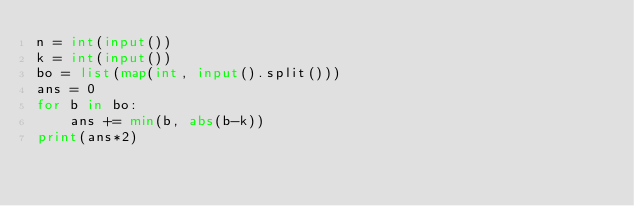<code> <loc_0><loc_0><loc_500><loc_500><_Python_>n = int(input())
k = int(input())
bo = list(map(int, input().split()))
ans = 0
for b in bo:
    ans += min(b, abs(b-k))
print(ans*2)</code> 